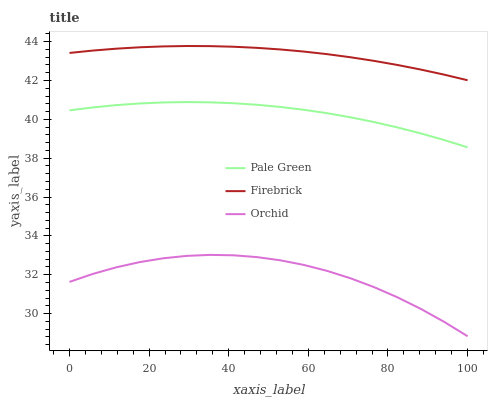Does Orchid have the minimum area under the curve?
Answer yes or no. Yes. Does Firebrick have the maximum area under the curve?
Answer yes or no. Yes. Does Pale Green have the minimum area under the curve?
Answer yes or no. No. Does Pale Green have the maximum area under the curve?
Answer yes or no. No. Is Firebrick the smoothest?
Answer yes or no. Yes. Is Orchid the roughest?
Answer yes or no. Yes. Is Pale Green the smoothest?
Answer yes or no. No. Is Pale Green the roughest?
Answer yes or no. No. Does Pale Green have the lowest value?
Answer yes or no. No. Does Firebrick have the highest value?
Answer yes or no. Yes. Does Pale Green have the highest value?
Answer yes or no. No. Is Orchid less than Pale Green?
Answer yes or no. Yes. Is Pale Green greater than Orchid?
Answer yes or no. Yes. Does Orchid intersect Pale Green?
Answer yes or no. No. 